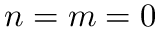Convert formula to latex. <formula><loc_0><loc_0><loc_500><loc_500>n = m = 0</formula> 